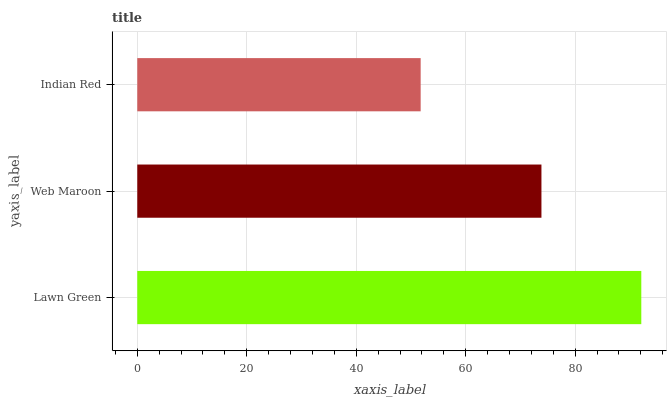Is Indian Red the minimum?
Answer yes or no. Yes. Is Lawn Green the maximum?
Answer yes or no. Yes. Is Web Maroon the minimum?
Answer yes or no. No. Is Web Maroon the maximum?
Answer yes or no. No. Is Lawn Green greater than Web Maroon?
Answer yes or no. Yes. Is Web Maroon less than Lawn Green?
Answer yes or no. Yes. Is Web Maroon greater than Lawn Green?
Answer yes or no. No. Is Lawn Green less than Web Maroon?
Answer yes or no. No. Is Web Maroon the high median?
Answer yes or no. Yes. Is Web Maroon the low median?
Answer yes or no. Yes. Is Indian Red the high median?
Answer yes or no. No. Is Indian Red the low median?
Answer yes or no. No. 